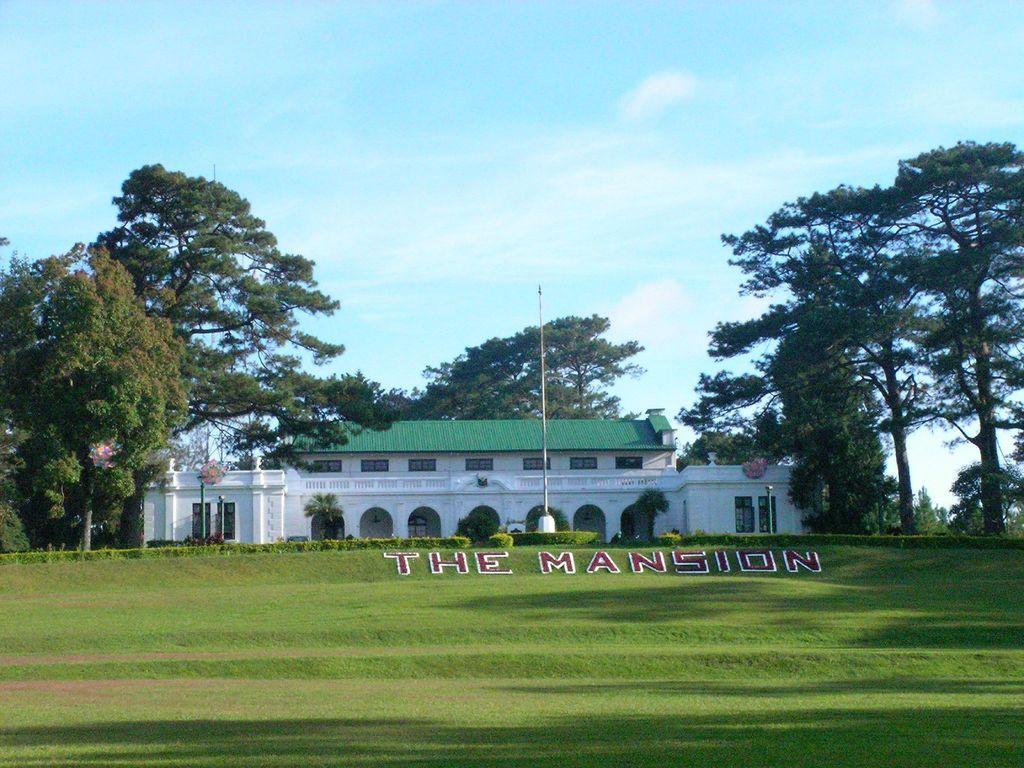In one or two sentences, can you explain what this image depicts? There is grass, pole, building and trees. 